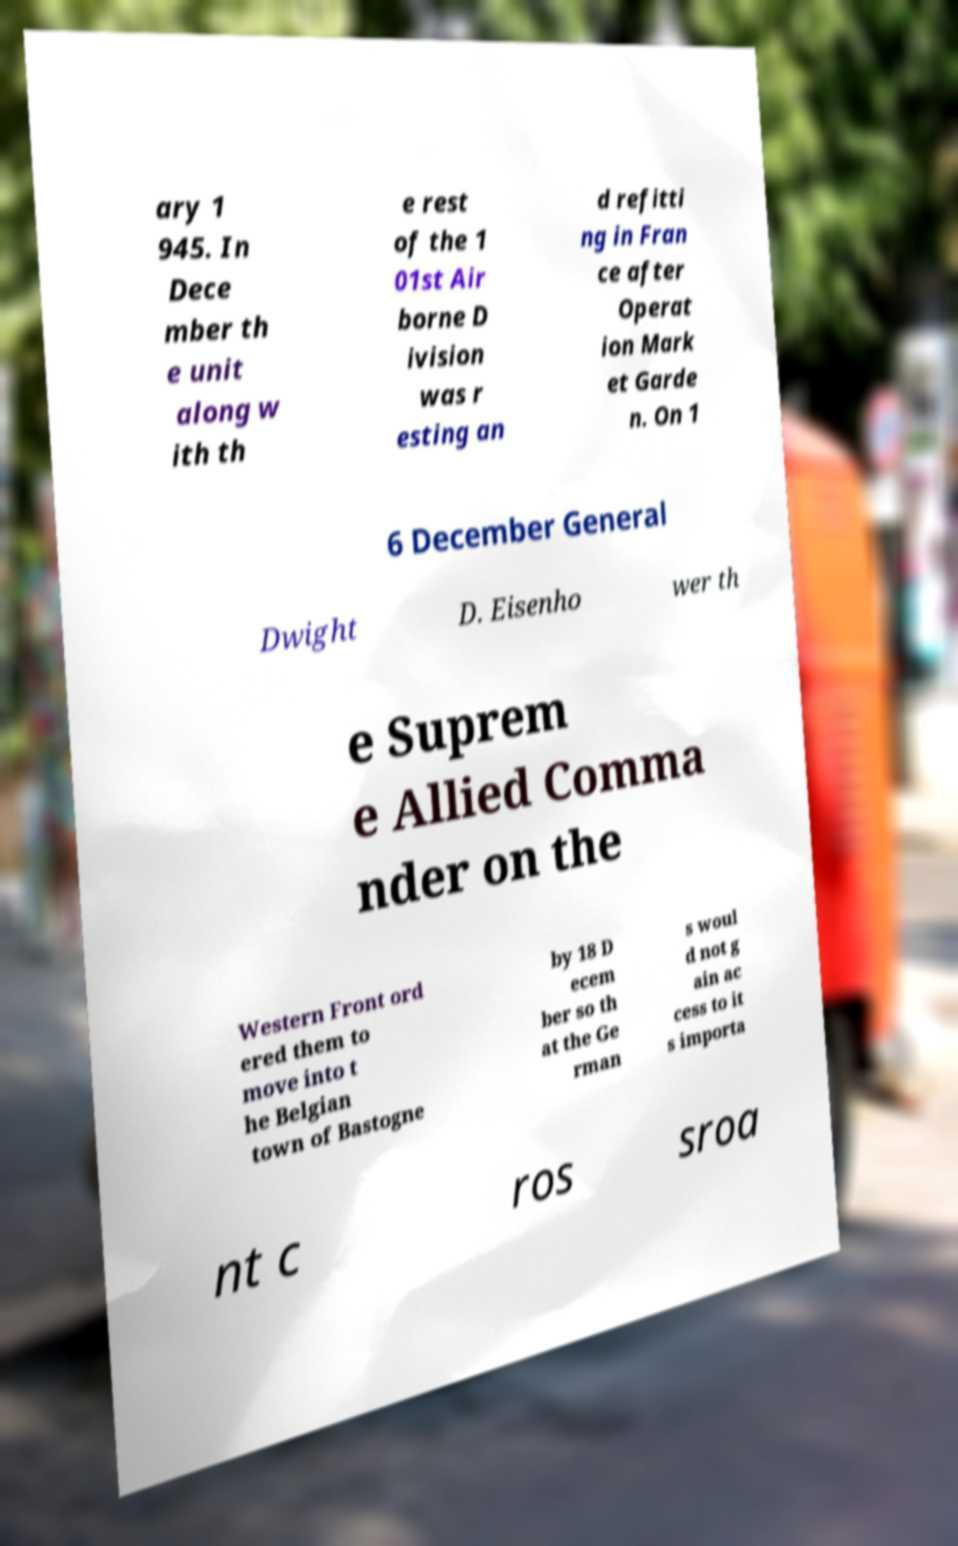Please read and relay the text visible in this image. What does it say? ary 1 945. In Dece mber th e unit along w ith th e rest of the 1 01st Air borne D ivision was r esting an d refitti ng in Fran ce after Operat ion Mark et Garde n. On 1 6 December General Dwight D. Eisenho wer th e Suprem e Allied Comma nder on the Western Front ord ered them to move into t he Belgian town of Bastogne by 18 D ecem ber so th at the Ge rman s woul d not g ain ac cess to it s importa nt c ros sroa 